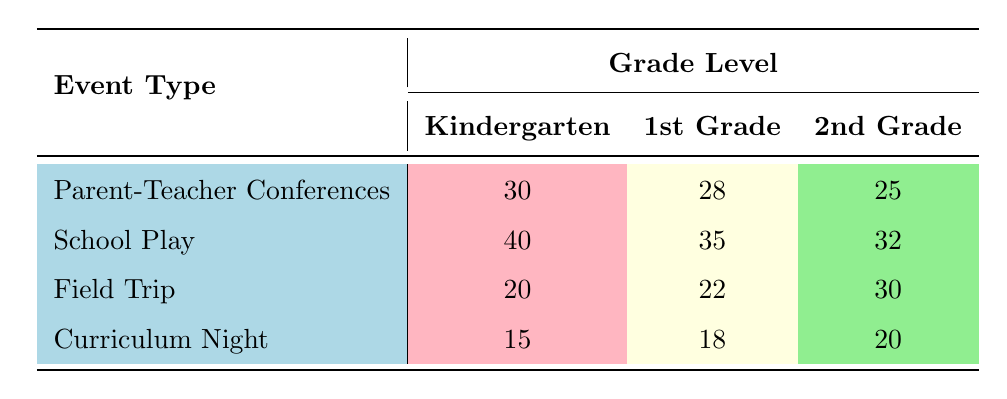What is the attendance count for Parent-Teacher Conferences in 1st Grade? The table shows an attendance count of 28 for Parent-Teacher Conferences specifically in the 1st Grade column.
Answer: 28 Which event had the highest attendance in Kindergarten? The School Play had the highest attendance in the Kindergarten column, with an attendance count of 40, compared to 30 for Parent-Teacher Conferences, 20 for the Field Trip, and 15 for Curriculum Night.
Answer: School Play What is the total attendance for Field Trip across all grade levels? To find the total attendance for Field Trips, we add the counts for Kindergarten (20), 1st Grade (22), and 2nd Grade (30): 20 + 22 + 30 = 72.
Answer: 72 Is the attendance for Curriculum Night higher than that for Field Trips in 2nd Grade? For Curriculum Night in 2nd Grade, the attendance count is 20. For Field Trips in 2nd Grade, the attendance count is 30. Since 20 is not higher than 30, the statement is false.
Answer: No What is the difference in attendance between the School Play and Parent-Teacher Conferences for 2nd Grade? For the School Play, the attendance count in 2nd Grade is 32, while for Parent-Teacher Conferences, it is 25. The difference is calculated as 32 - 25 = 7.
Answer: 7 Which event type has the lowest total attendance across all grade levels? The total attendance for each event type needs to be calculated: Parent-Teacher Conferences (30 + 28 + 25 = 83), School Play (40 + 35 + 32 = 107), Field Trip (20 + 22 + 30 = 72), and Curriculum Night (15 + 18 + 20 = 53). The lowest total is for Curriculum Night, with an attendance of 53.
Answer: Curriculum Night Are there more parents attending School Plays than Field Trips in 1st Grade? In 1st Grade, the attendance for School Plays is 35, while for Field Trips it is 22. Since 35 is greater than 22, the statement is true.
Answer: Yes What is the average attendance count for all events in 2nd Grade? The attendance counts for 2nd Grade are 25 (Parent-Teacher Conferences), 32 (School Play), 30 (Field Trip), and 20 (Curriculum Night). Summing these gives 25 + 32 + 30 + 20 = 117, then dividing by 4 gives an average of 117 / 4 = 29.25.
Answer: 29.25 